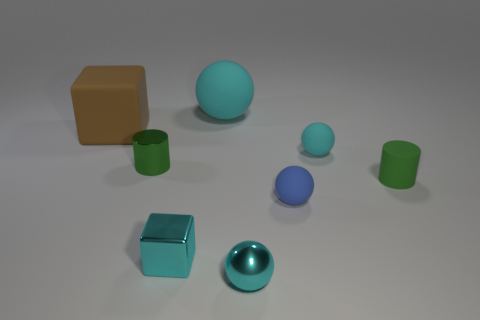How many tiny rubber objects are the same shape as the small green metal thing?
Give a very brief answer. 1. How big is the matte object in front of the small green cylinder that is on the right side of the large cyan sphere?
Keep it short and to the point. Small. Do the blue matte object and the cyan metallic sphere have the same size?
Make the answer very short. Yes. Are there any rubber things that are to the left of the rubber sphere that is on the left side of the rubber sphere in front of the rubber cylinder?
Make the answer very short. Yes. The blue ball has what size?
Make the answer very short. Small. What number of other things are the same size as the brown matte object?
Your answer should be compact. 1. There is another small object that is the same shape as the brown object; what is it made of?
Your answer should be very brief. Metal. What shape is the matte object that is both in front of the large cyan matte object and behind the tiny cyan rubber object?
Give a very brief answer. Cube. There is a small green object that is right of the large cyan sphere; what is its shape?
Provide a short and direct response. Cylinder. How many rubber things are both on the left side of the blue rubber sphere and on the right side of the tiny green metallic cylinder?
Offer a very short reply. 1. 